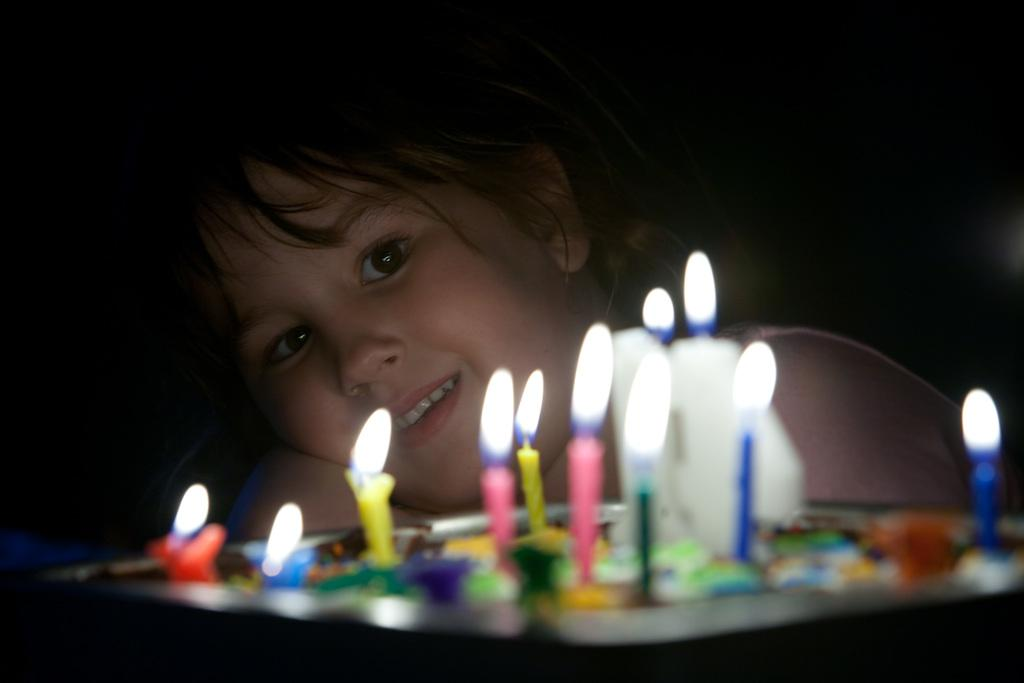What is the main object in the center of the image? There is a plate in the center of the image. What is on the plate? The plate contains different color candles. Can you describe the girl in the background of the image? The girl is in the background of the image, and she is smiling, as indicated by her facial expression. How much profit did the ants make from the candles in the image? There are no ants present in the image, and therefore no profit can be calculated. 